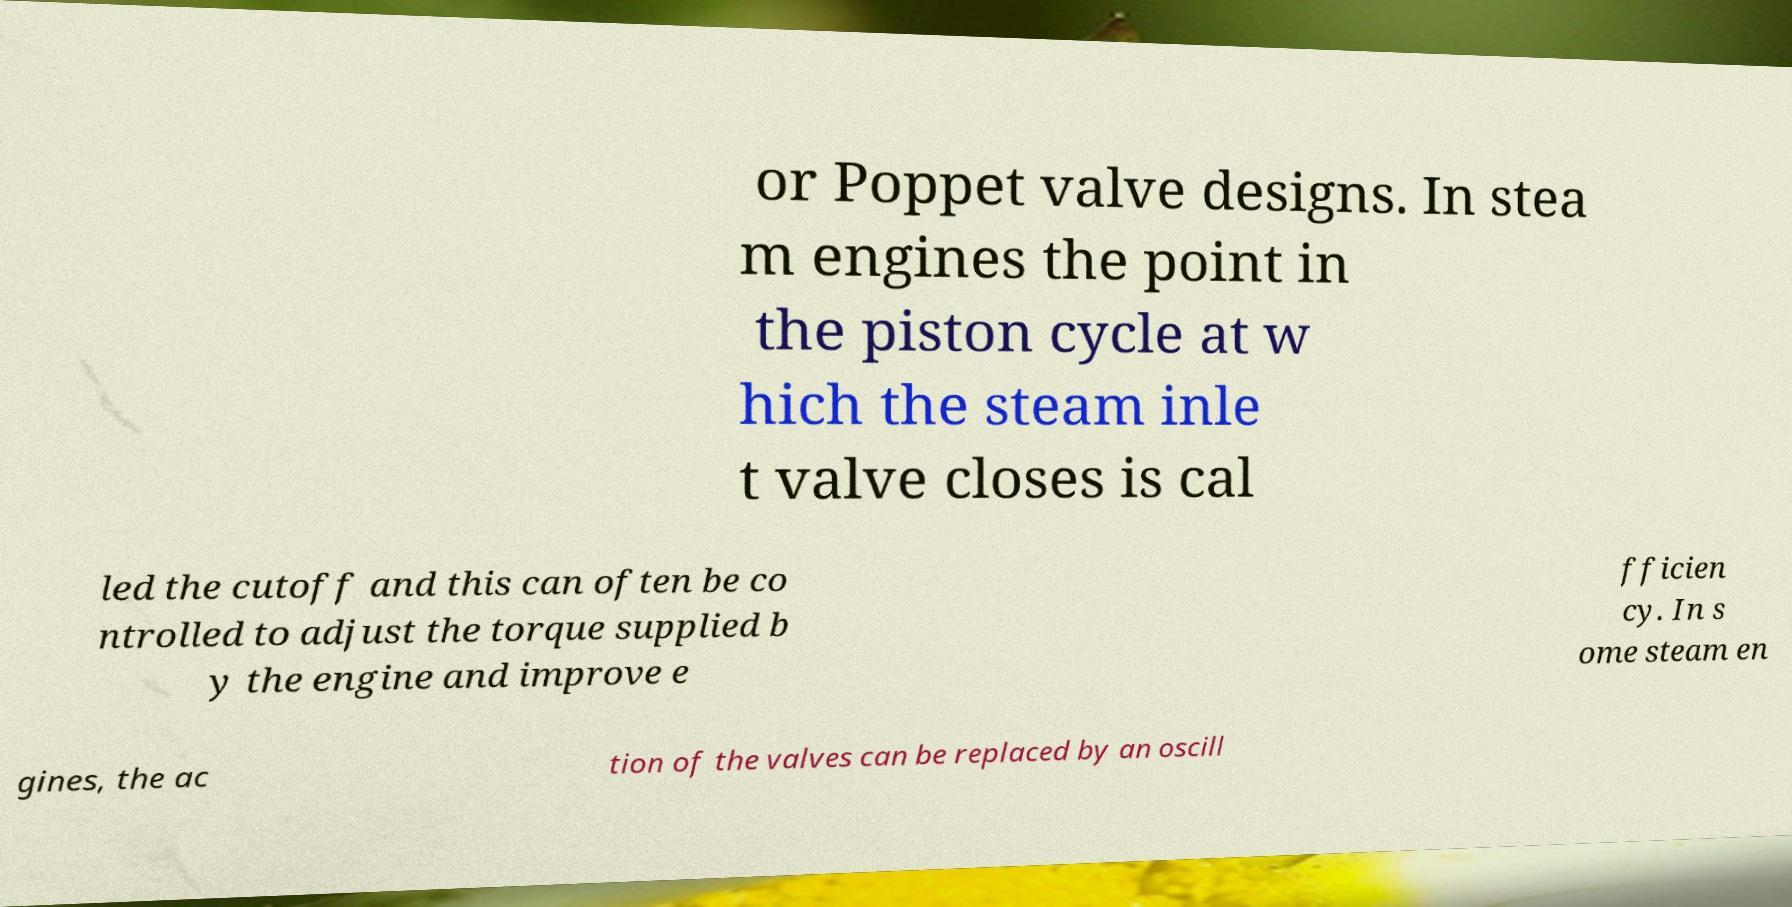Could you extract and type out the text from this image? or Poppet valve designs. In stea m engines the point in the piston cycle at w hich the steam inle t valve closes is cal led the cutoff and this can often be co ntrolled to adjust the torque supplied b y the engine and improve e fficien cy. In s ome steam en gines, the ac tion of the valves can be replaced by an oscill 